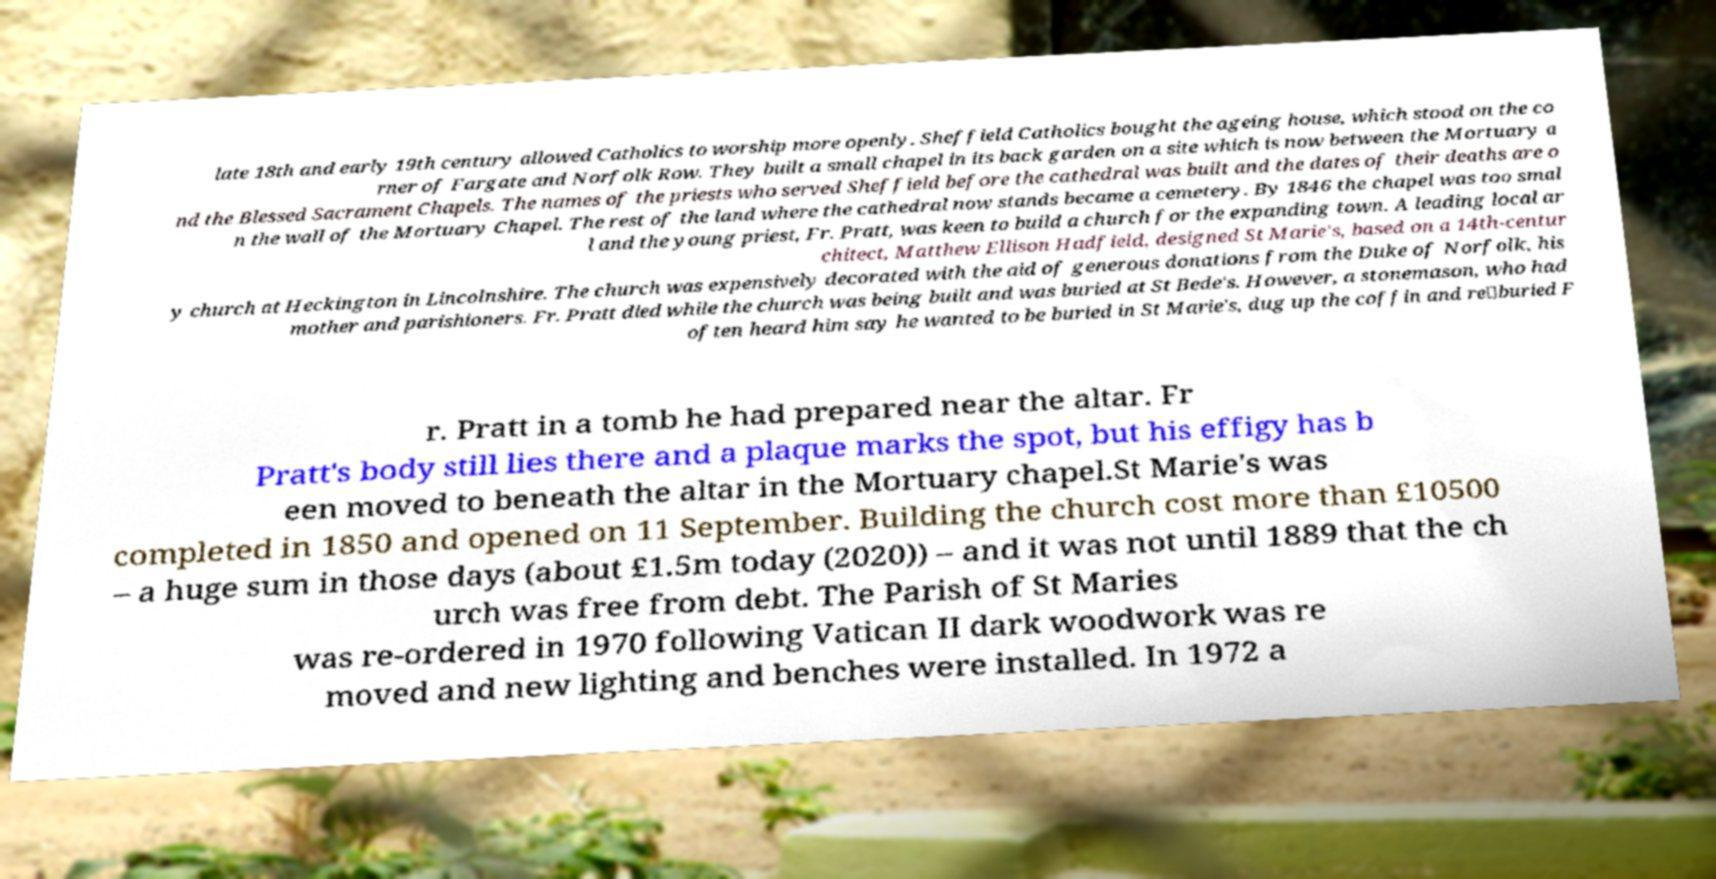Can you read and provide the text displayed in the image?This photo seems to have some interesting text. Can you extract and type it out for me? late 18th and early 19th century allowed Catholics to worship more openly. Sheffield Catholics bought the ageing house, which stood on the co rner of Fargate and Norfolk Row. They built a small chapel in its back garden on a site which is now between the Mortuary a nd the Blessed Sacrament Chapels. The names of the priests who served Sheffield before the cathedral was built and the dates of their deaths are o n the wall of the Mortuary Chapel. The rest of the land where the cathedral now stands became a cemetery. By 1846 the chapel was too smal l and the young priest, Fr. Pratt, was keen to build a church for the expanding town. A leading local ar chitect, Matthew Ellison Hadfield, designed St Marie's, based on a 14th-centur y church at Heckington in Lincolnshire. The church was expensively decorated with the aid of generous donations from the Duke of Norfolk, his mother and parishioners. Fr. Pratt died while the church was being built and was buried at St Bede's. However, a stonemason, who had often heard him say he wanted to be buried in St Marie's, dug up the coffin and re‑buried F r. Pratt in a tomb he had prepared near the altar. Fr Pratt's body still lies there and a plaque marks the spot, but his effigy has b een moved to beneath the altar in the Mortuary chapel.St Marie's was completed in 1850 and opened on 11 September. Building the church cost more than £10500 – a huge sum in those days (about £1.5m today (2020)) – and it was not until 1889 that the ch urch was free from debt. The Parish of St Maries was re-ordered in 1970 following Vatican II dark woodwork was re moved and new lighting and benches were installed. In 1972 a 